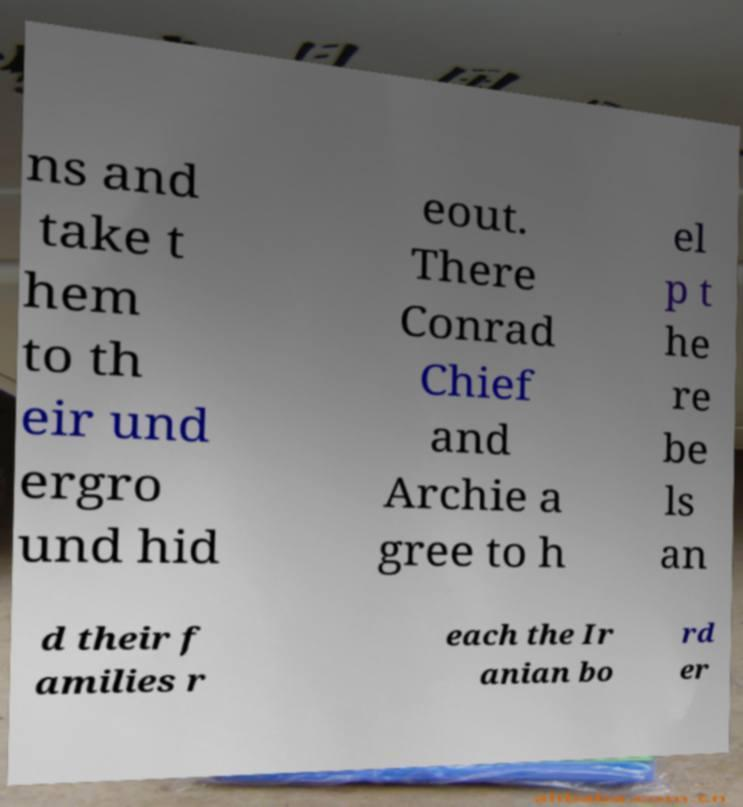There's text embedded in this image that I need extracted. Can you transcribe it verbatim? ns and take t hem to th eir und ergro und hid eout. There Conrad Chief and Archie a gree to h el p t he re be ls an d their f amilies r each the Ir anian bo rd er 